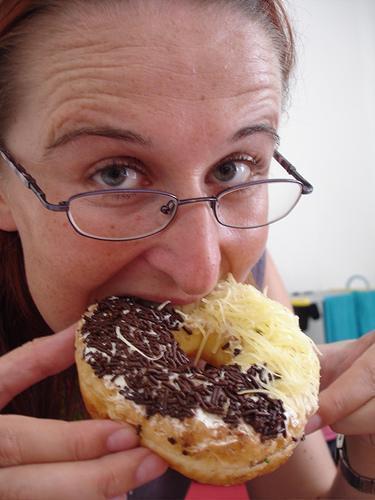How many birds are trying to steal the donut?
Give a very brief answer. 0. 